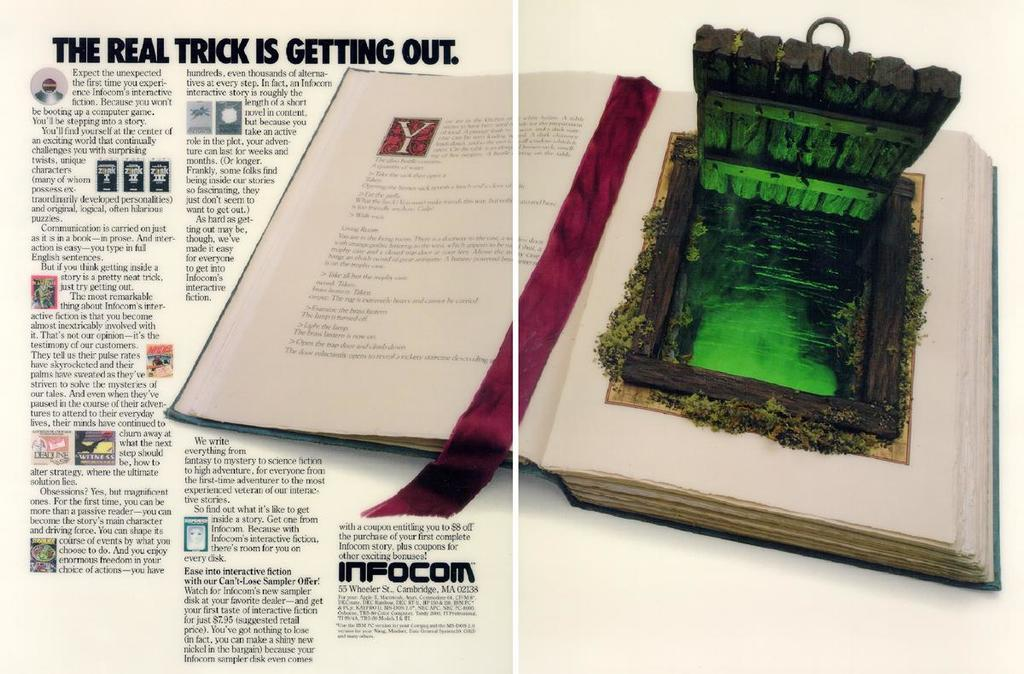<image>
Render a clear and concise summary of the photo. A magazine page shows a book with a portal door and the title "The real trick is getting out" 